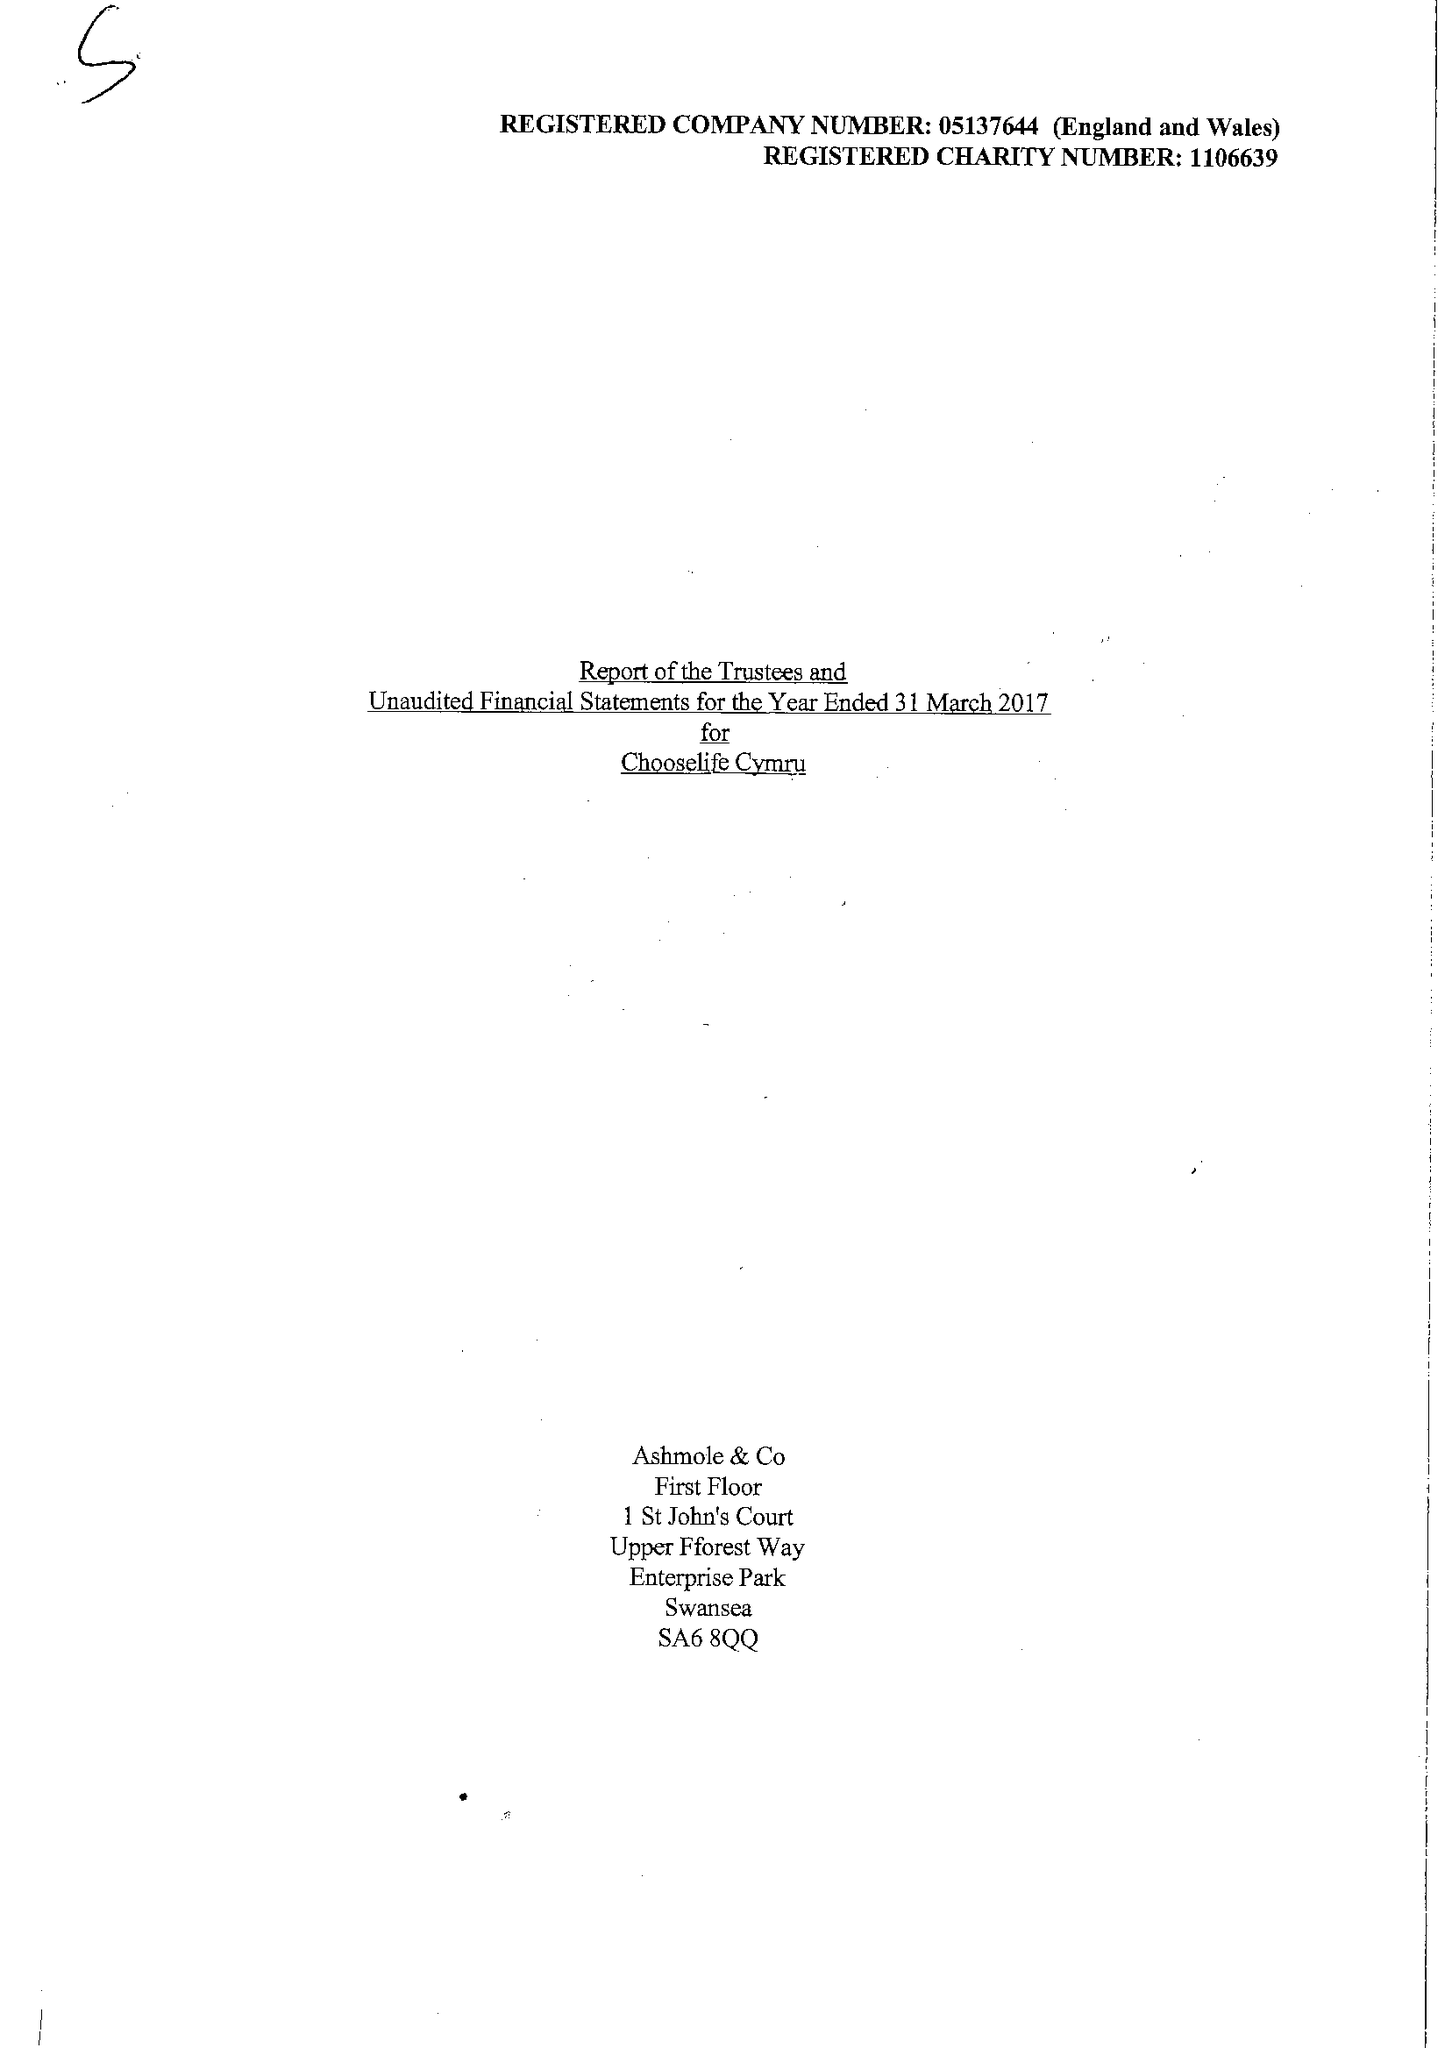What is the value for the spending_annually_in_british_pounds?
Answer the question using a single word or phrase. 318248.00 